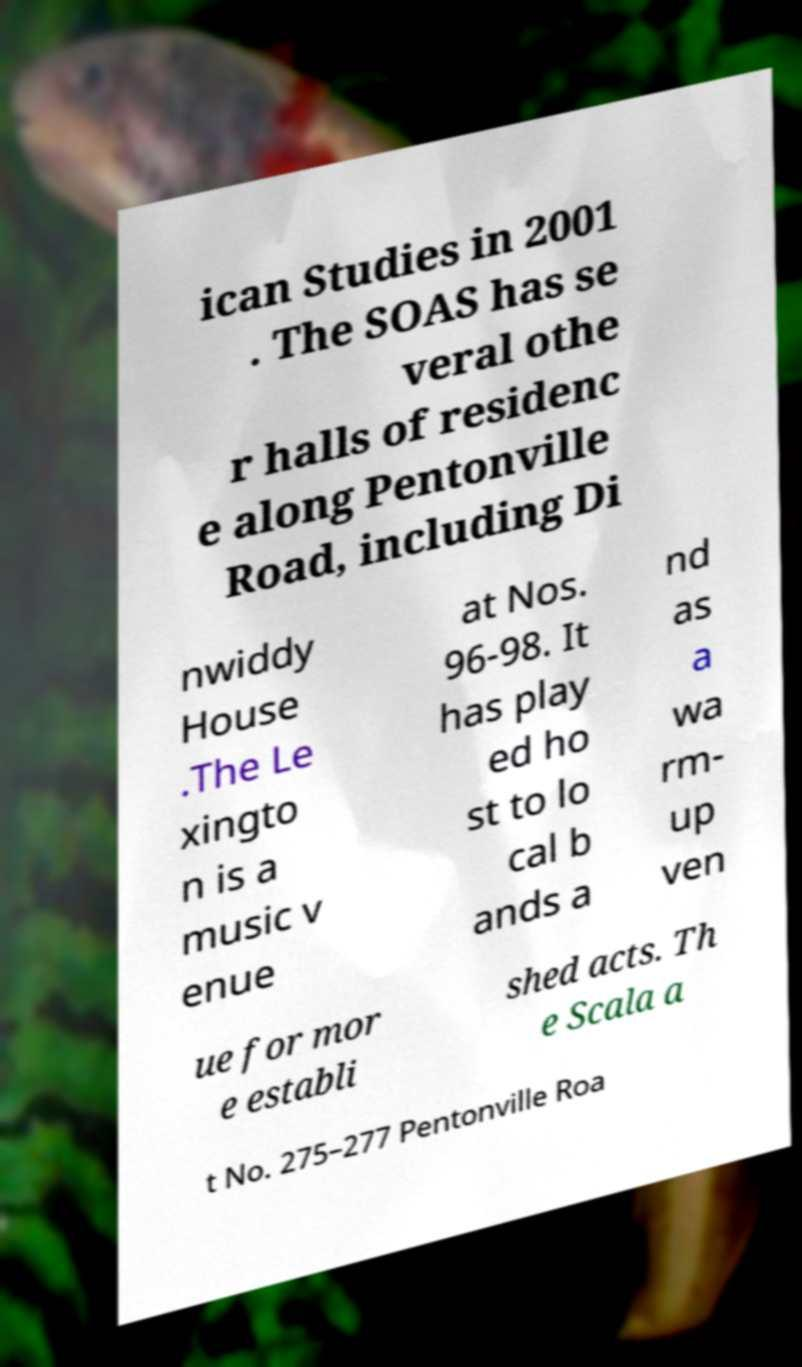Please identify and transcribe the text found in this image. ican Studies in 2001 . The SOAS has se veral othe r halls of residenc e along Pentonville Road, including Di nwiddy House .The Le xingto n is a music v enue at Nos. 96-98. It has play ed ho st to lo cal b ands a nd as a wa rm- up ven ue for mor e establi shed acts. Th e Scala a t No. 275–277 Pentonville Roa 